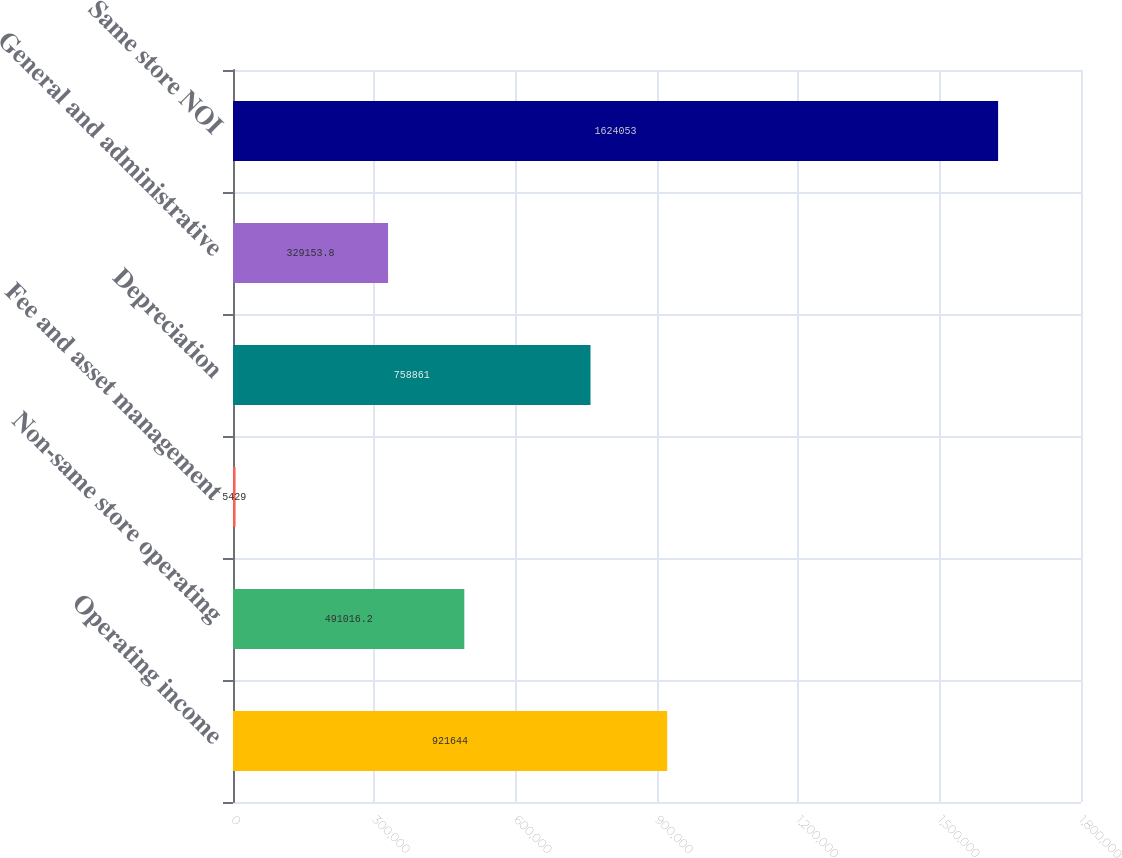Convert chart. <chart><loc_0><loc_0><loc_500><loc_500><bar_chart><fcel>Operating income<fcel>Non-same store operating<fcel>Fee and asset management<fcel>Depreciation<fcel>General and administrative<fcel>Same store NOI<nl><fcel>921644<fcel>491016<fcel>5429<fcel>758861<fcel>329154<fcel>1.62405e+06<nl></chart> 